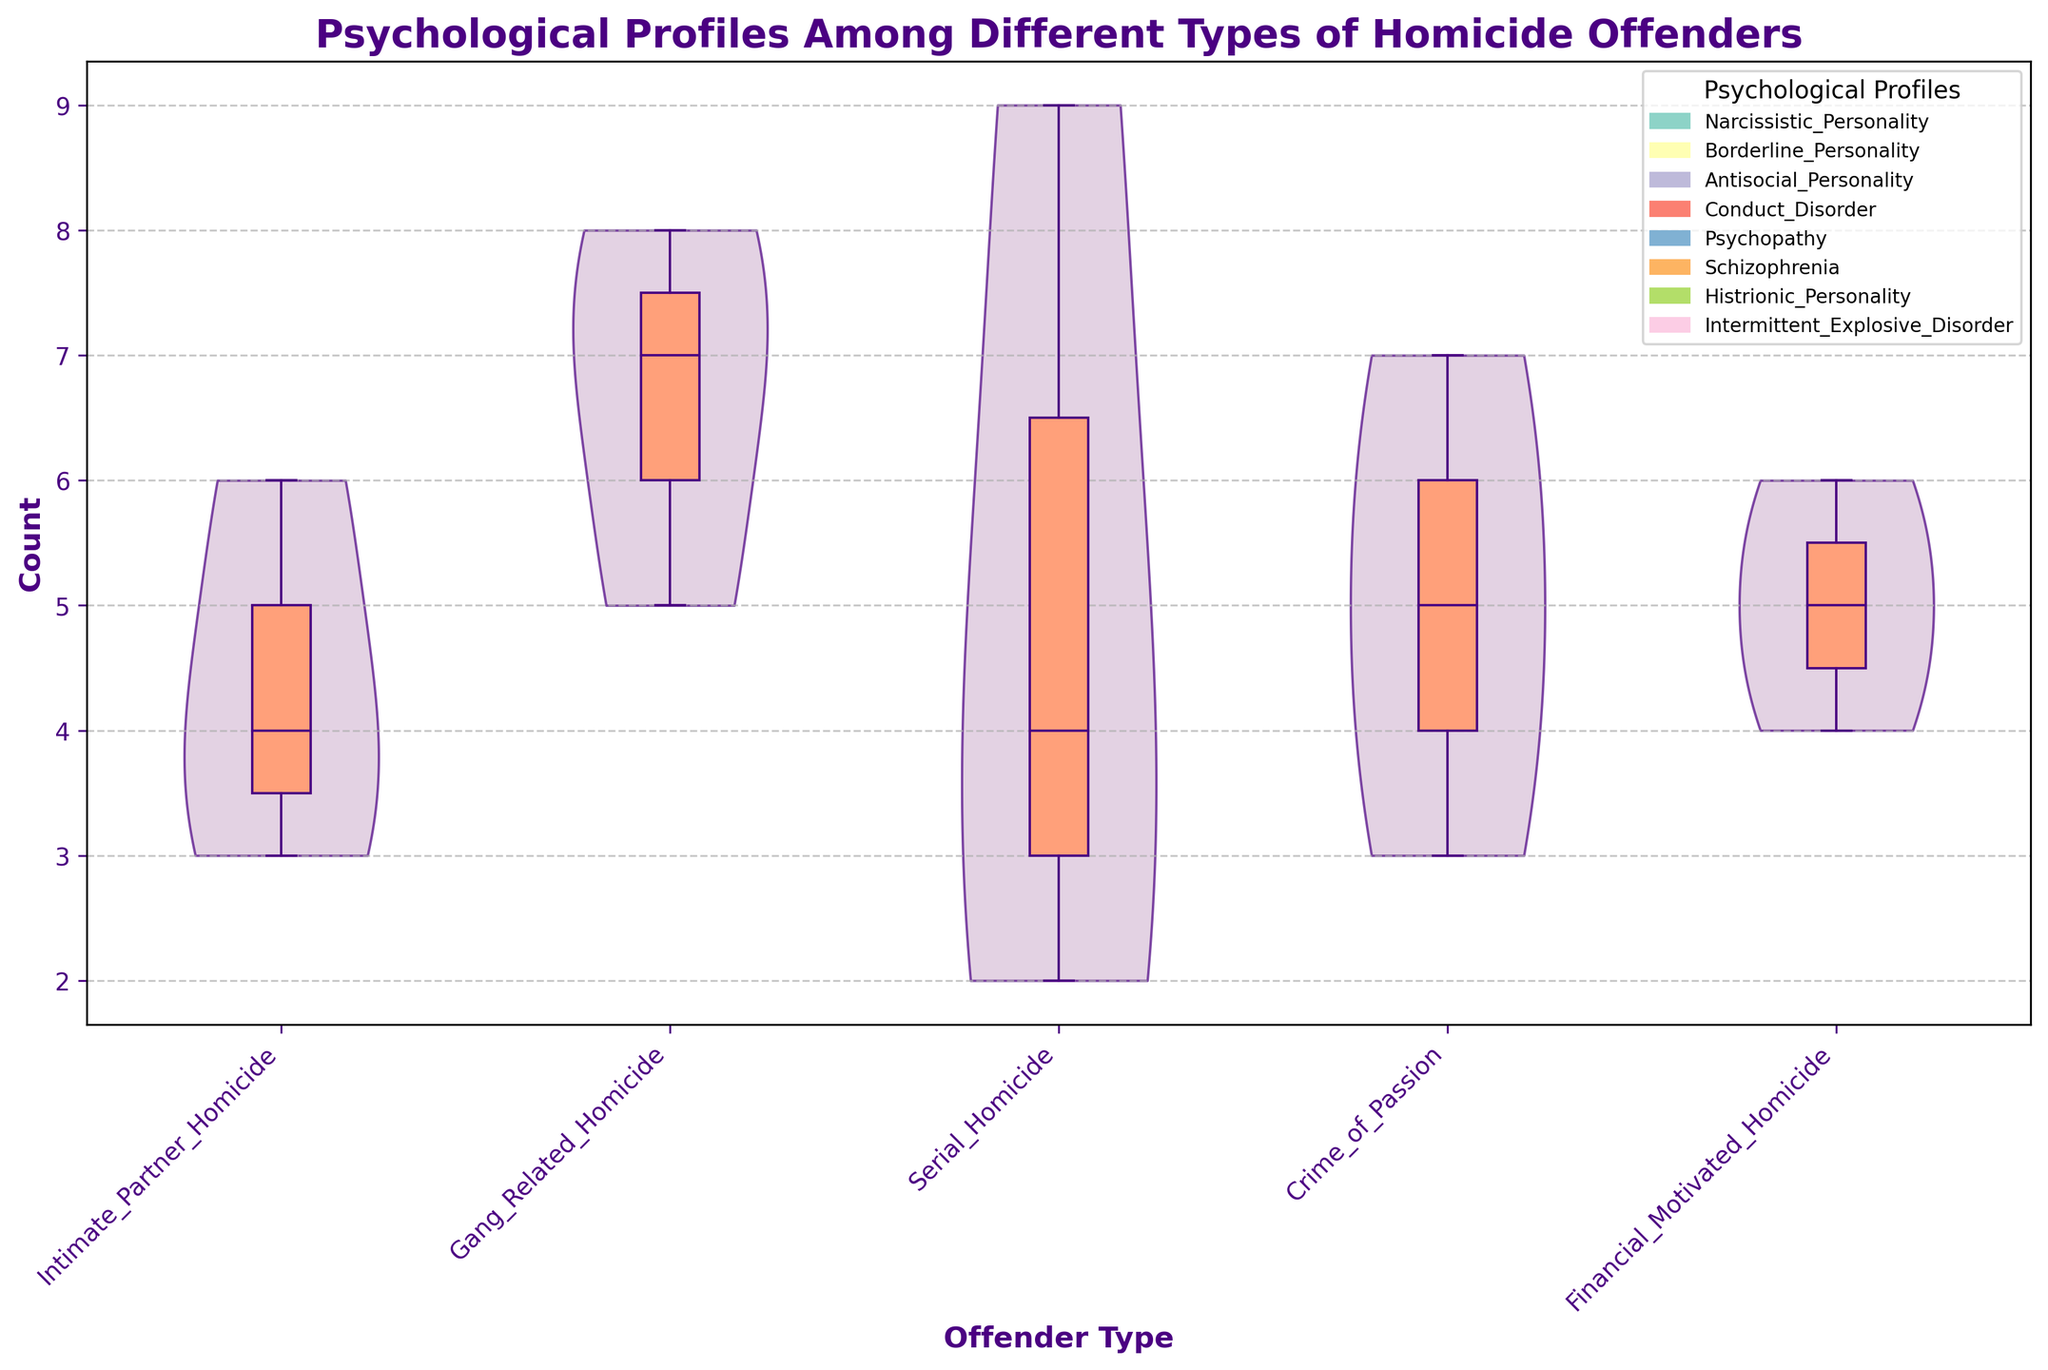What's the title of the plot? The title is clearly stated at the top of the plot, which reads: "Psychological Profiles Among Different Types of Homicide Offenders".
Answer: Psychological Profiles Among Different Types of Homicide Offenders What do the colors of the violin plots represent? The color of the violin plots is uniform, so it does not distinguish between different psychological profiles; however, the overall structure shows distribution across offender types.
Answer: They represent the distribution of counts for various offender types Which offender type has the highest median value according to the box plots? By examining the vertical position of the horizontal lines inside the boxes, which denote the medians, it is clear that the Gang Related Homicide type shows the highest median value on the y-axis.
Answer: Gang Related Homicide How many distinct psychological profiles are represented in the legend? The legend helps to identify different psychological profiles using rectangles. Counting the rectangles provides the answer.
Answer: Six Which psychological profile appears most frequently in Serial Homicide offenders? By looking at the data points marked along the y-axis under Serial Homicide, the profile with the highest count is Psychopathy, with a value of 9.
Answer: Psychopathy Compare the distribution spreads (range) of counts for Intimate Partner Homicide and Crime of Passion. Which has a wider range? Check the length of the violin plots and the box plot whiskers. Intimate Partner Homicide appears to have counts ranging from 3 to 6, while Crime of Passion ranges from 3 to 7.
Answer: Crime of Passion Which psychological profile is not present in Financial Motivated Homicide offenders according to the plot? The plot legends help determine which profiles are marked across different types. There is no reference to Psychopathy in Financial Motivated Homicide.
Answer: Intermittent Explosive Disorder What's the average count for the profiles in Gang Related Homicide? Summing up the counts for Gang Related profiles (5+8+7 = 20) and dividing by the number of profiles (3) gives the average.
Answer: 6.67 What is the count range for Narcissistic Personality across different offender types? Look at all the violins where Narcissistic Personality is marked, count values are 4 for Intimate Partner Homicide, 4 for Serial Homicide, and 6 for Financial Motivated Homicide, ranging from 4 to 6.
Answer: 4 to 6 